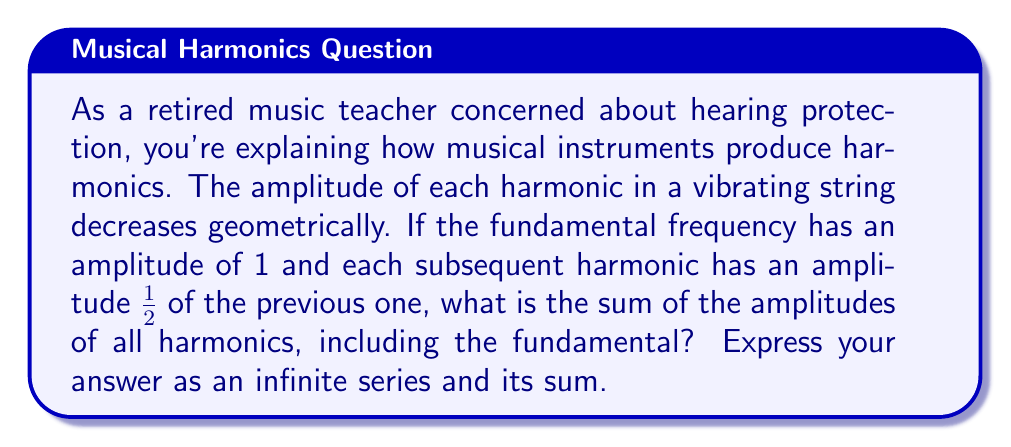Teach me how to tackle this problem. Let's approach this step-by-step:

1) First, let's identify the pattern in the series:
   - Fundamental (1st harmonic): $1$
   - 2nd harmonic: $\frac{1}{2}$
   - 3rd harmonic: $\frac{1}{4}$
   - 4th harmonic: $\frac{1}{8}$
   And so on...

2) We can see that this forms a geometric series with:
   - First term $a = 1$
   - Common ratio $r = \frac{1}{2}$

3) The infinite series can be written as:

   $$S_{\infty} = 1 + \frac{1}{2} + \frac{1}{4} + \frac{1}{8} + ...$$

4) For an infinite geometric series with $|r| < 1$, the sum is given by the formula:

   $$S_{\infty} = \frac{a}{1-r}$$

   Where $a$ is the first term and $r$ is the common ratio.

5) In our case, $a = 1$ and $r = \frac{1}{2}$. Let's substitute these values:

   $$S_{\infty} = \frac{1}{1-\frac{1}{2}} = \frac{1}{\frac{1}{2}} = 2$$

Therefore, the sum of the amplitudes of all harmonics, including the fundamental, is 2.

This result shows that even though we're adding an infinite number of terms, the sum converges to a finite value. In the context of hearing protection, it's important to note that while higher harmonics contribute to the richness of sound, their amplitudes decrease rapidly, and the total energy of the sound is finite.
Answer: The infinite series is $$1 + \frac{1}{2} + \frac{1}{4} + \frac{1}{8} + ...$$
and its sum is 2. 